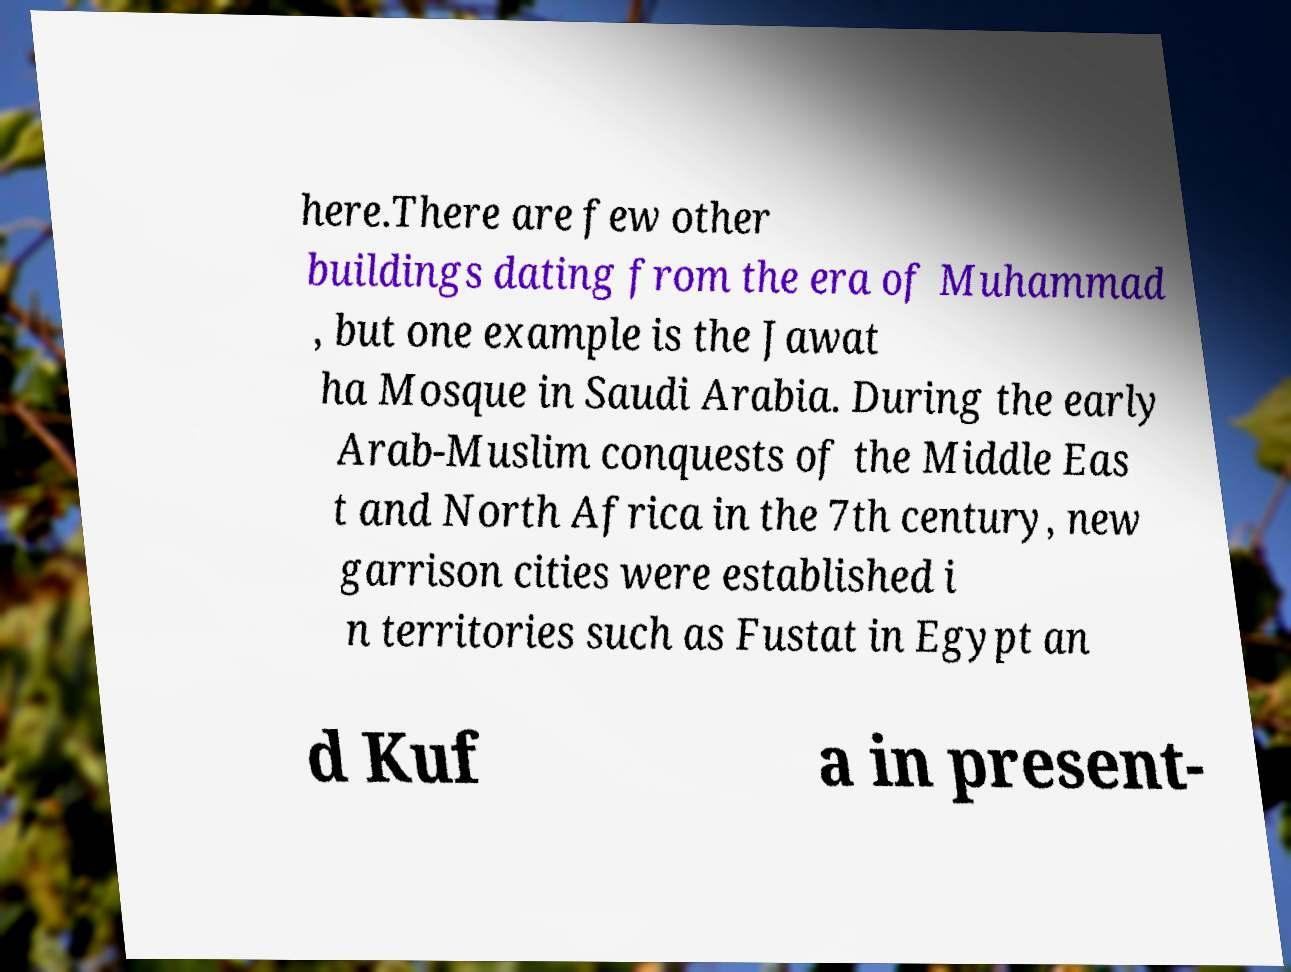Please read and relay the text visible in this image. What does it say? here.There are few other buildings dating from the era of Muhammad , but one example is the Jawat ha Mosque in Saudi Arabia. During the early Arab-Muslim conquests of the Middle Eas t and North Africa in the 7th century, new garrison cities were established i n territories such as Fustat in Egypt an d Kuf a in present- 